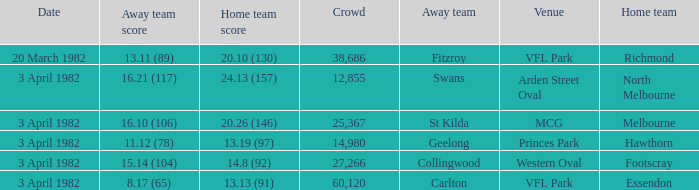What score did the home team of north melbourne get? 24.13 (157). 